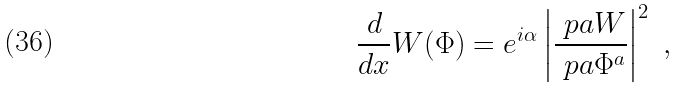<formula> <loc_0><loc_0><loc_500><loc_500>\frac { d } { d x } W ( \Phi ) = e ^ { i \alpha } \left | \frac { \ p a W } { \ p a \Phi ^ { a } } \right | ^ { 2 } \ ,</formula> 